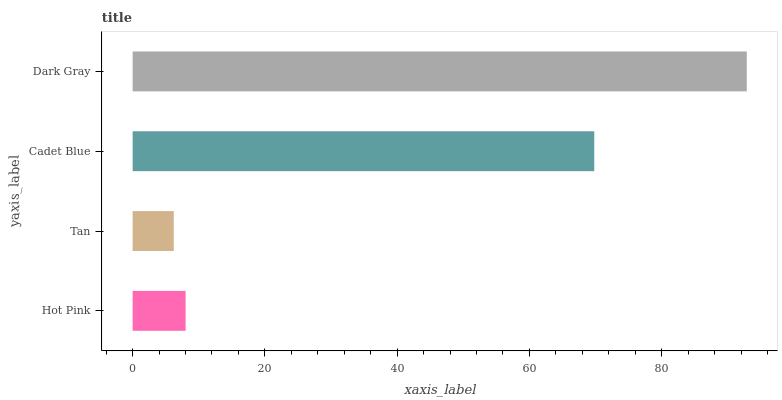Is Tan the minimum?
Answer yes or no. Yes. Is Dark Gray the maximum?
Answer yes or no. Yes. Is Cadet Blue the minimum?
Answer yes or no. No. Is Cadet Blue the maximum?
Answer yes or no. No. Is Cadet Blue greater than Tan?
Answer yes or no. Yes. Is Tan less than Cadet Blue?
Answer yes or no. Yes. Is Tan greater than Cadet Blue?
Answer yes or no. No. Is Cadet Blue less than Tan?
Answer yes or no. No. Is Cadet Blue the high median?
Answer yes or no. Yes. Is Hot Pink the low median?
Answer yes or no. Yes. Is Dark Gray the high median?
Answer yes or no. No. Is Tan the low median?
Answer yes or no. No. 